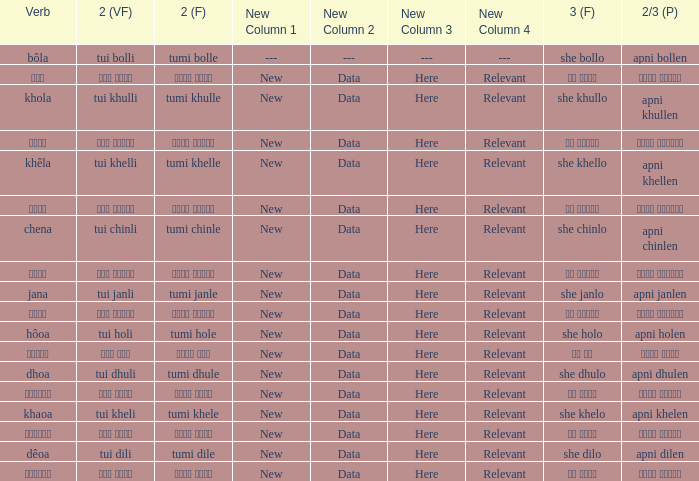What is the 2nd verb for Khola? Tumi khulle. 